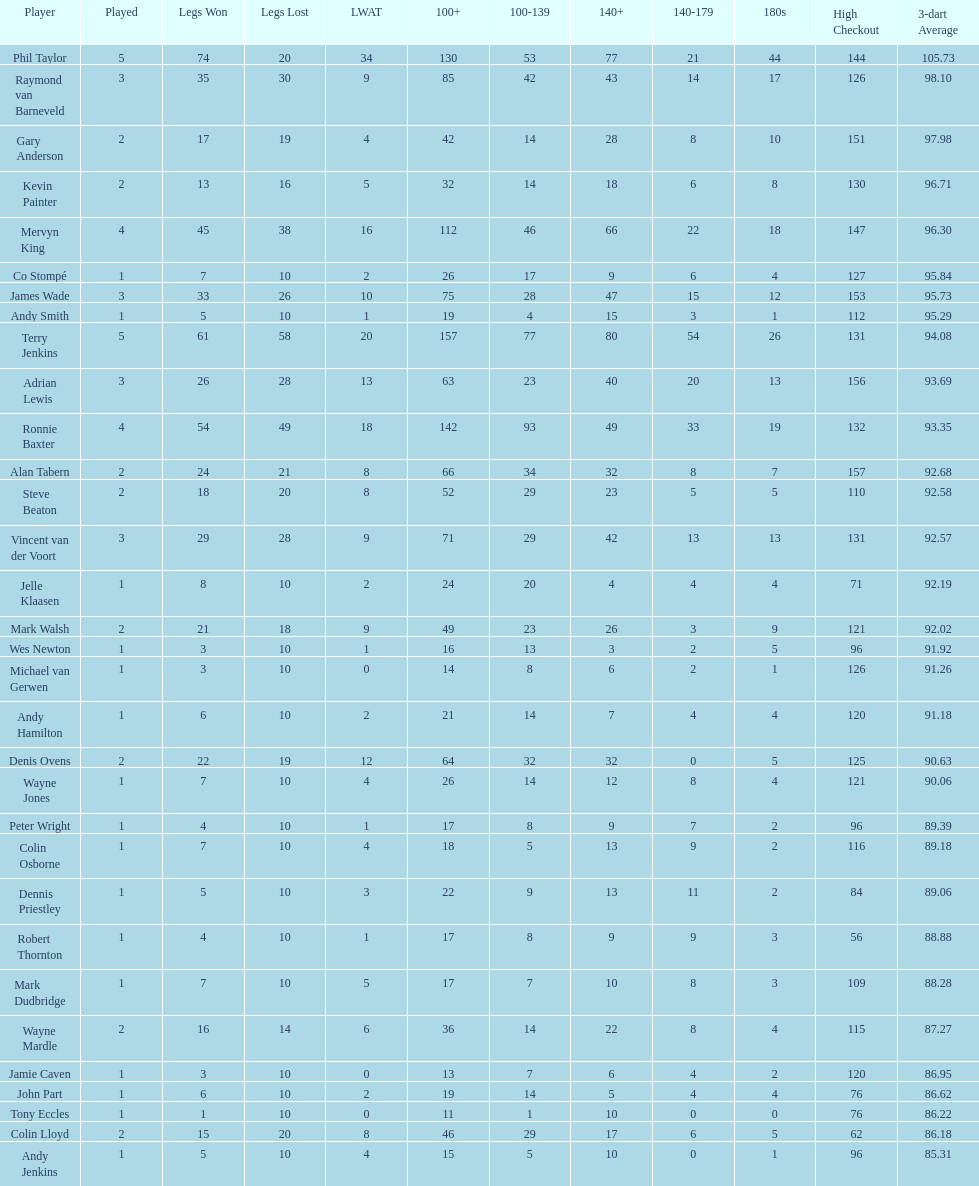What were the total number of legs won by ronnie baxter? 54. 